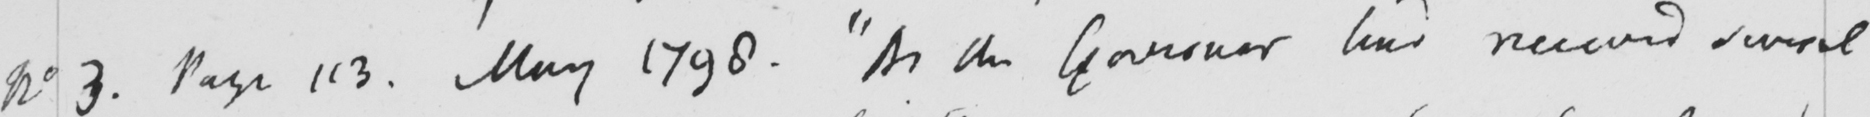Transcribe the text shown in this historical manuscript line. No 3 . Page 113 . May 1798 .  " As the governor has received several 